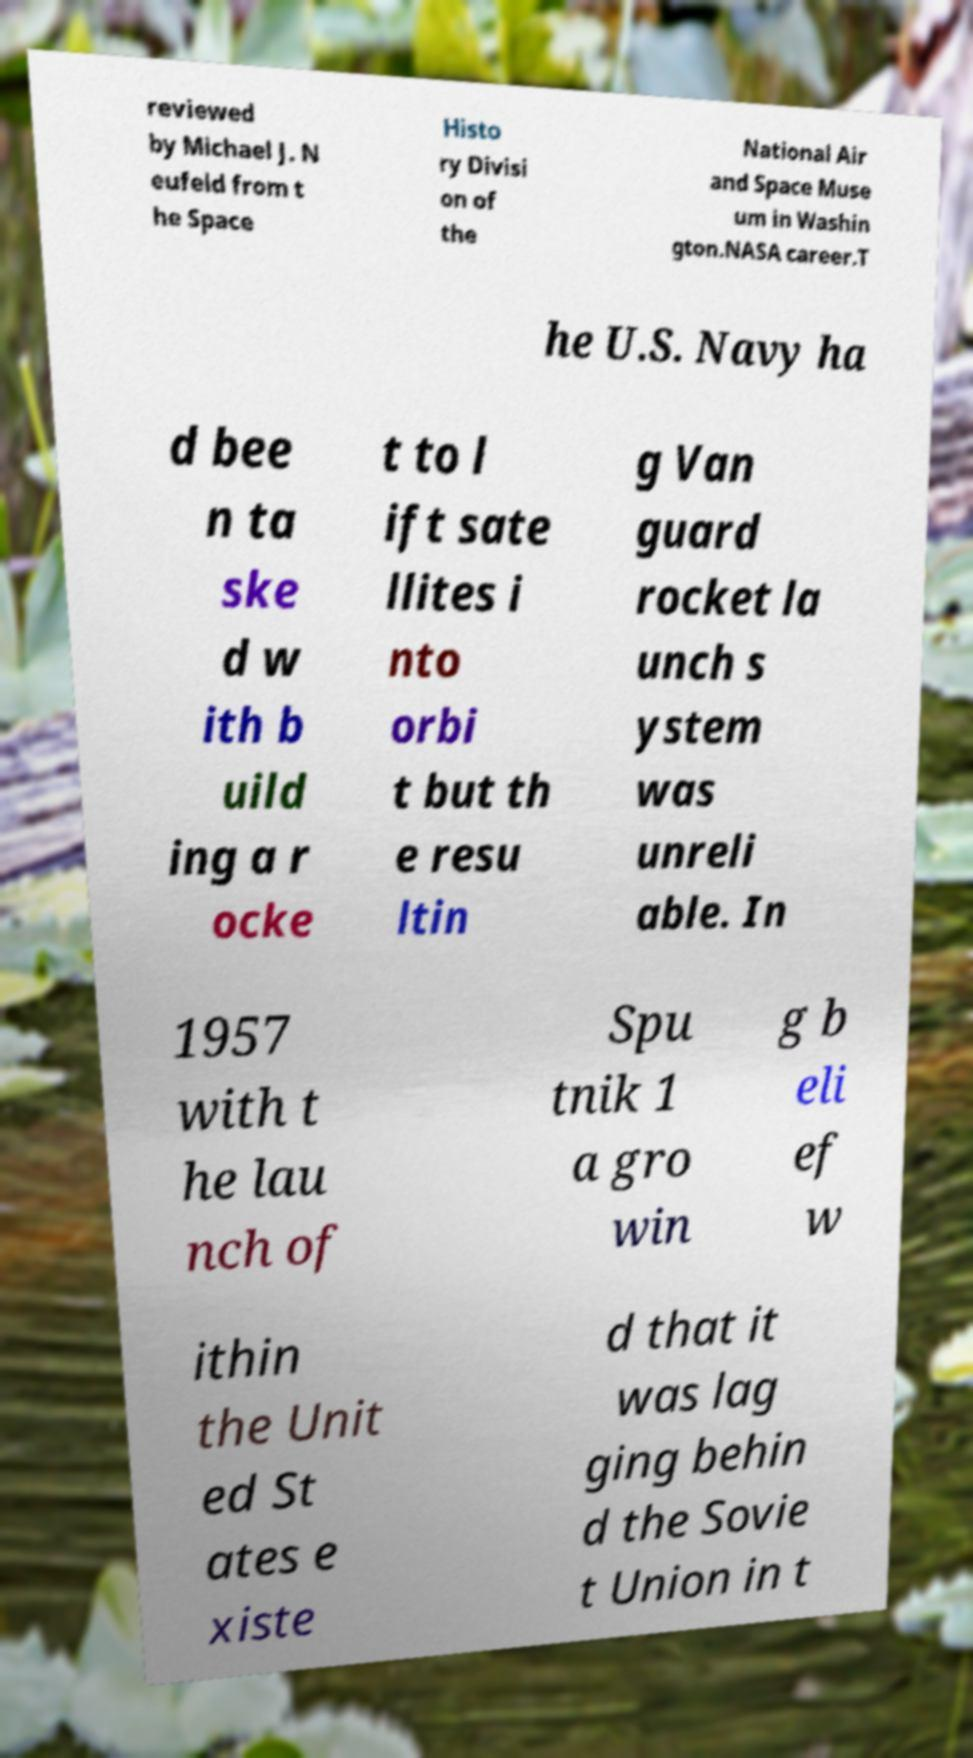Could you assist in decoding the text presented in this image and type it out clearly? reviewed by Michael J. N eufeld from t he Space Histo ry Divisi on of the National Air and Space Muse um in Washin gton.NASA career.T he U.S. Navy ha d bee n ta ske d w ith b uild ing a r ocke t to l ift sate llites i nto orbi t but th e resu ltin g Van guard rocket la unch s ystem was unreli able. In 1957 with t he lau nch of Spu tnik 1 a gro win g b eli ef w ithin the Unit ed St ates e xiste d that it was lag ging behin d the Sovie t Union in t 